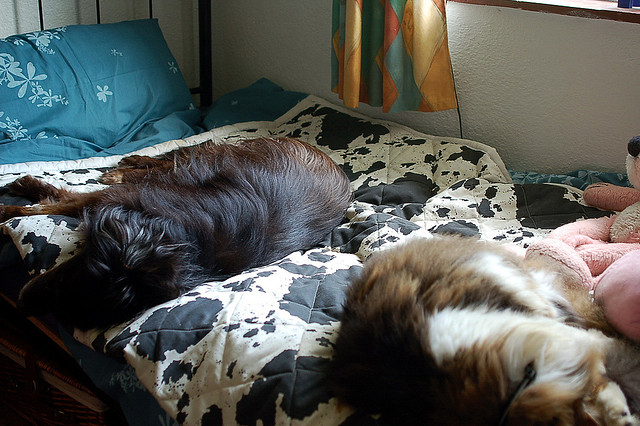What time of day do you think this photo was taken? Given the natural light coming through the window and the shadows in the room, it seems likely that the photo was taken during the day. The lighting suggests a late morning or early afternoon ambiance, when the sun is bright but not yet at its peak. Do you think the dogs have been resting here long? Dogs often enjoy long stretches of rest, and given their relaxed postures and the peaceful environment, it's quite possible that they've settled in for a leisurely nap and have been enjoying their rest for a while. 